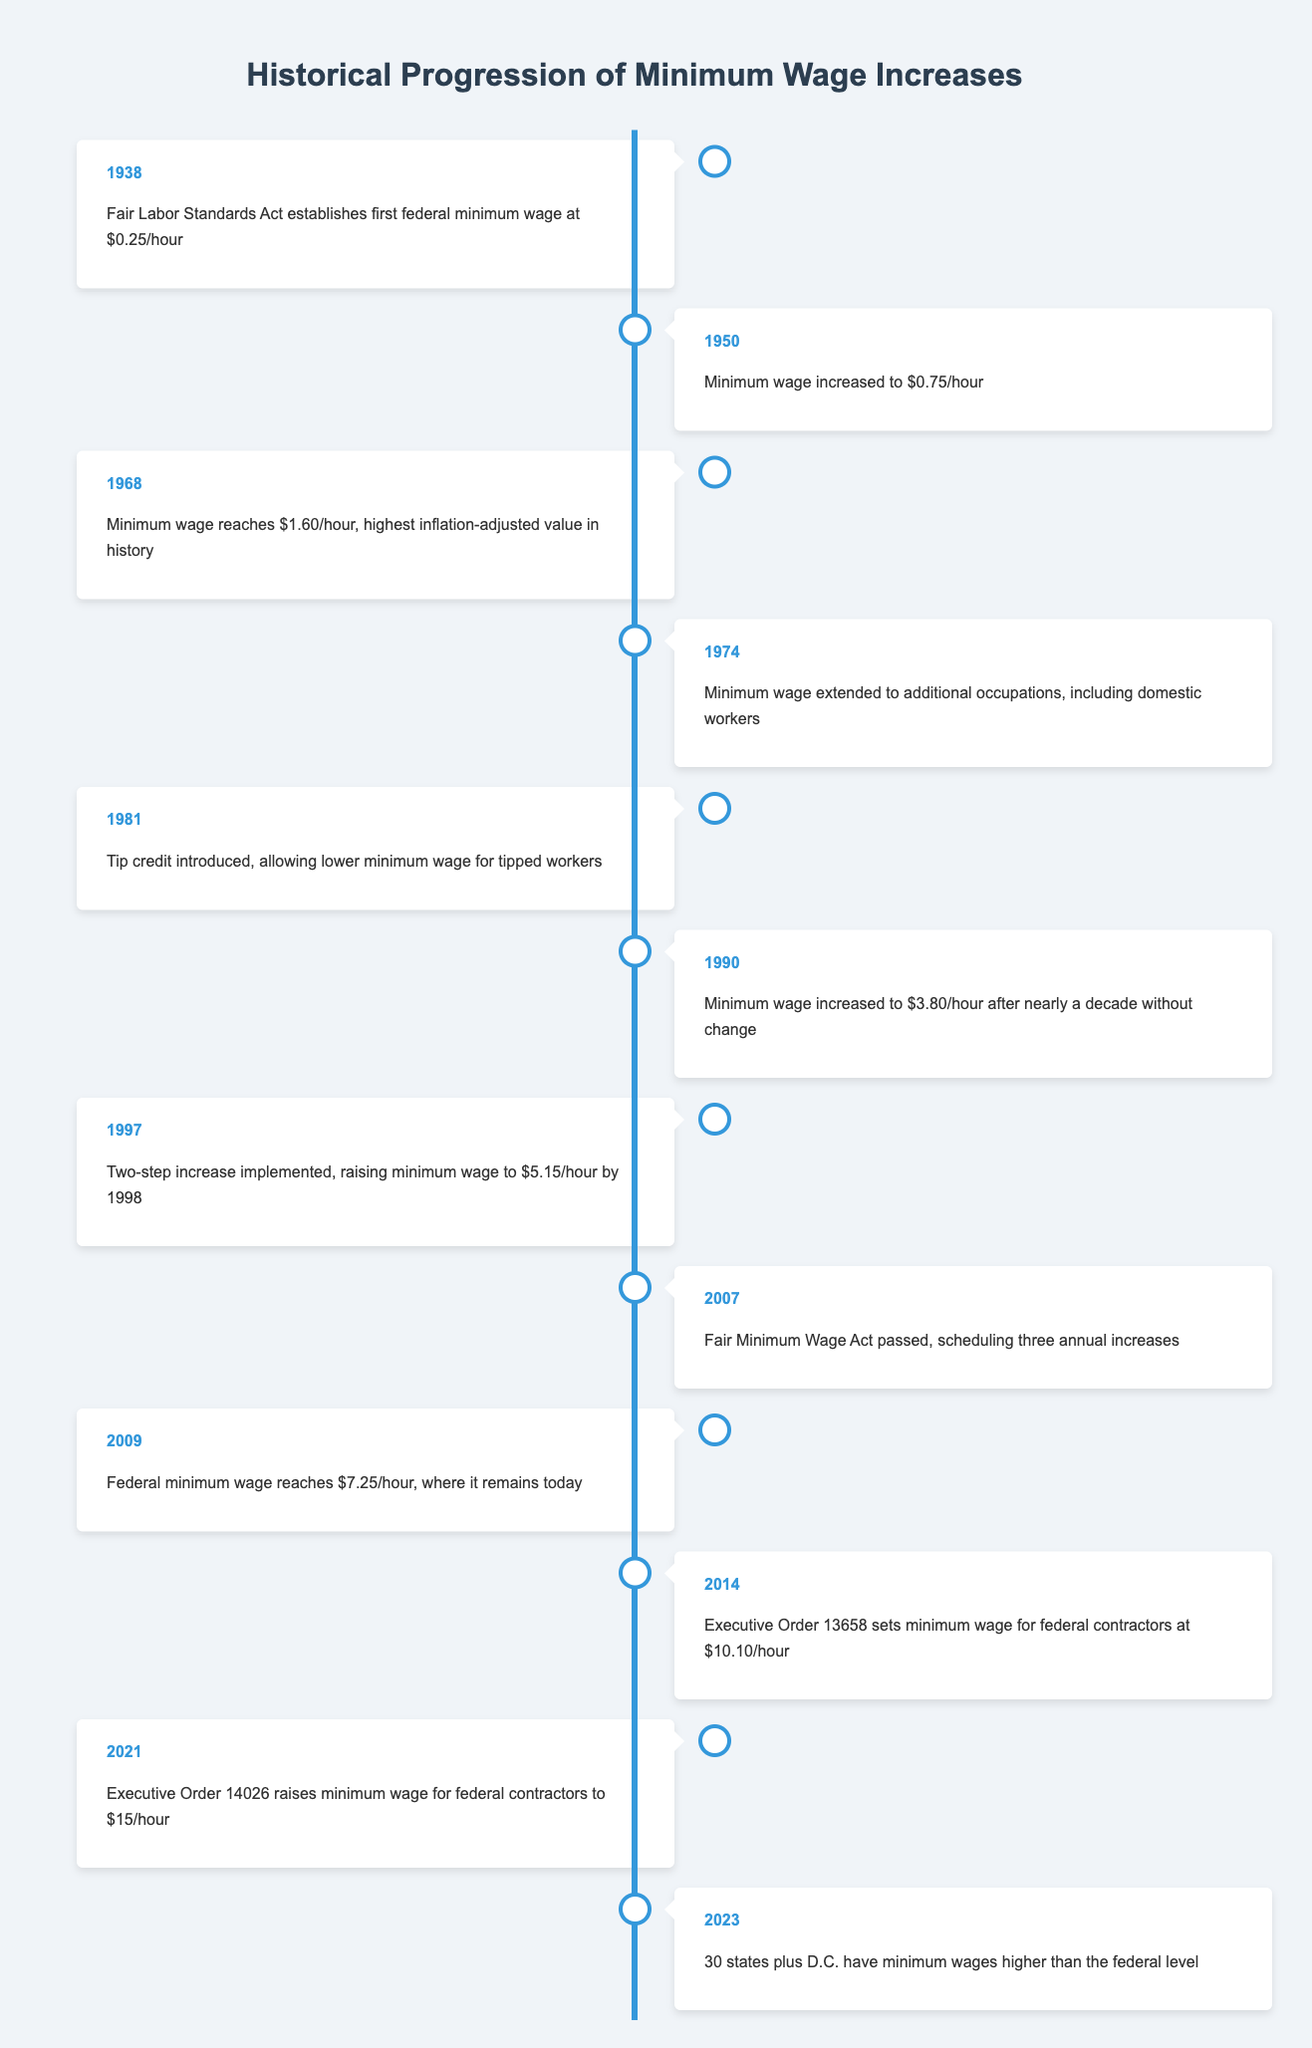What year was the first federal minimum wage established? According to the table, the first federal minimum wage was established in 1938 under the Fair Labor Standards Act.
Answer: 1938 What was the minimum wage in 1968? The table indicates that the minimum wage reached $1.60 per hour in 1968, which is noted as the highest inflation-adjusted value in history.
Answer: $1.60/hour How many years after 1950 was the minimum wage increased to $3.80? The minimum wage was increased to $3.80/hour in 1990, which is 40 years after 1950.
Answer: 40 years Was the minimum wage ever reduced between 1938 and 2023? The table does not show any instances of the minimum wage being reduced between 1938 and 2023. All entries indicate increases or adjustments rather than reductions.
Answer: No What was the minimum wage for federal contractors set at in 2014? According to the table, the minimum wage for federal contractors was set at $10.10/hour in 2014 under Executive Order 13658.
Answer: $10.10/hour How much did the federal minimum wage increase from 2007 to 2009? The federal minimum wage increased from $5.15/hour in 2007 to $7.25/hour in 2009. The difference is $2.10/hour.
Answer: $2.10/hour What is the status of minimum wages in states as of 2023? By 2023, the table states that 30 states plus D.C. have minimum wages that are higher than the federal level, indicating a trend of local increases.
Answer: Higher than federal What significant change occurred in 2021 regarding federal contractors? In 2021, Executive Order 14026 raised the minimum wage for federal contractors to $15/hour, reflecting a notable increase from previous years.
Answer: $15/hour What happened in 1974 regarding minimum wage coverage? In 1974, the minimum wage was extended to additional occupations, including domestic workers, indicating a broadening of minimum wage protections.
Answer: Extended to additional occupations 